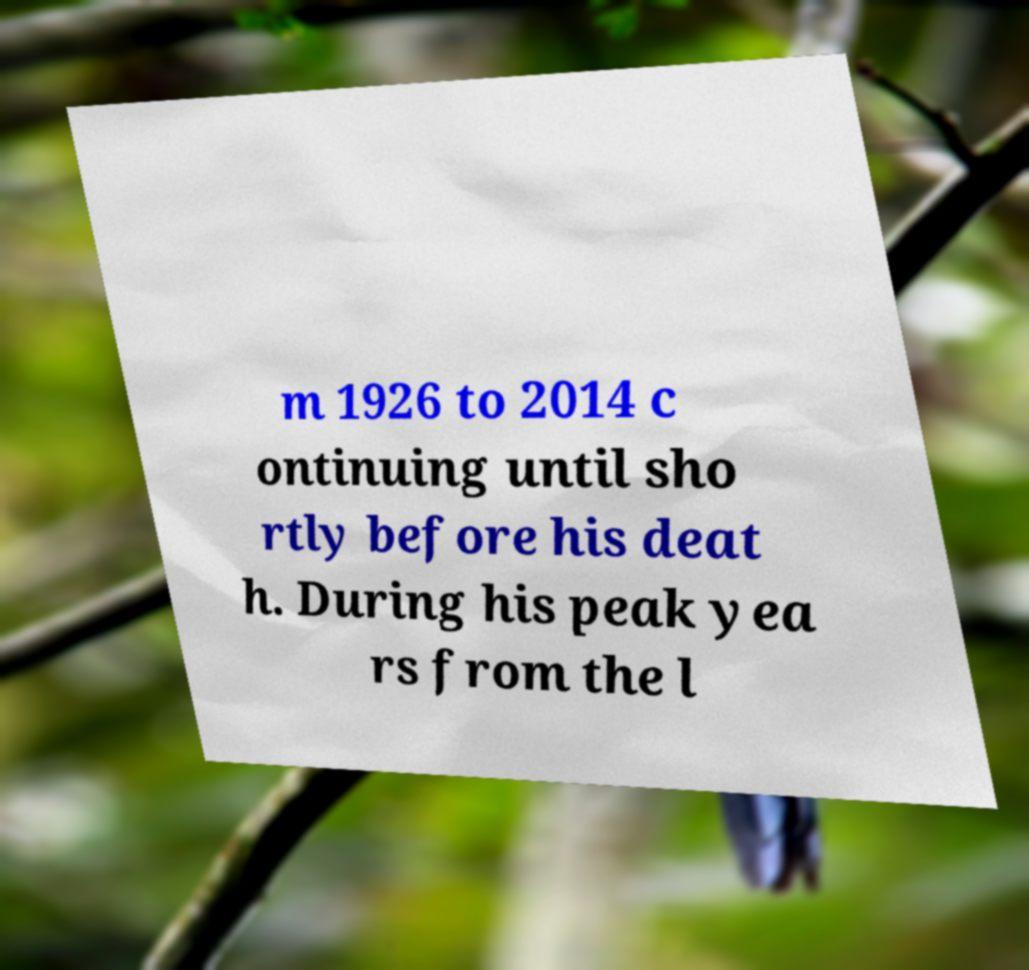I need the written content from this picture converted into text. Can you do that? m 1926 to 2014 c ontinuing until sho rtly before his deat h. During his peak yea rs from the l 